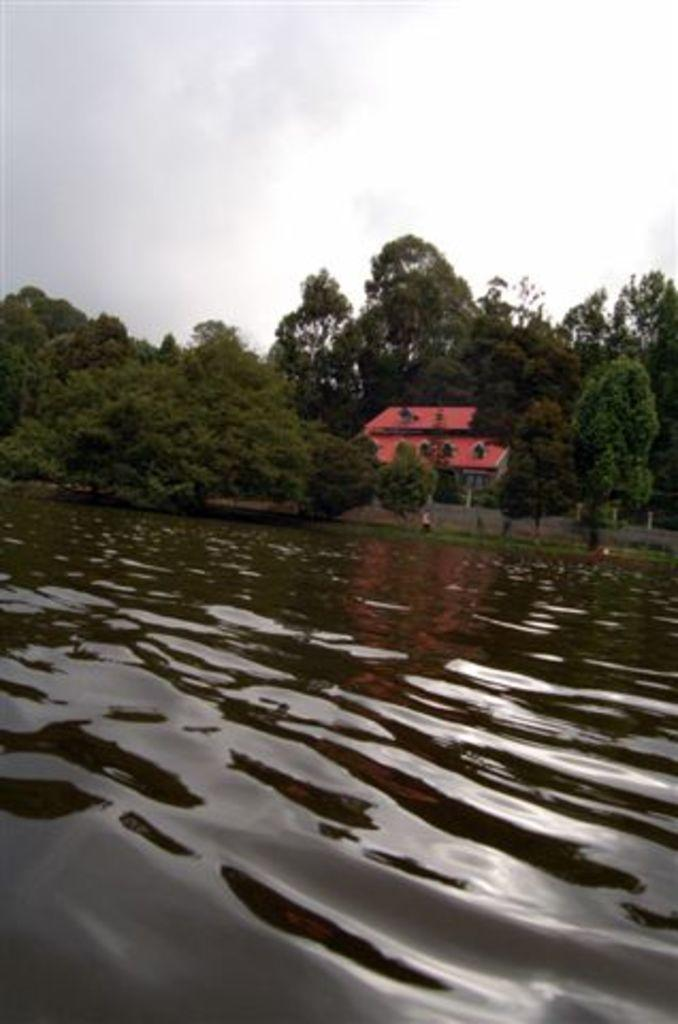What is the primary element in the image? There is water in the image. What can be seen in the background of the image? There is a building and trees in the background of the image. What is the color of the building? The building is orange in color. What is the color of the trees? The trees are green in color. What is visible in the background of the image besides the building and trees? The sky is visible in the background of the image. What is the color of the sky? The sky is white in color. What type of support can be seen holding up the sky in the image? There is no support holding up the sky in the image; it is a natural phenomenon and does not require any support. 